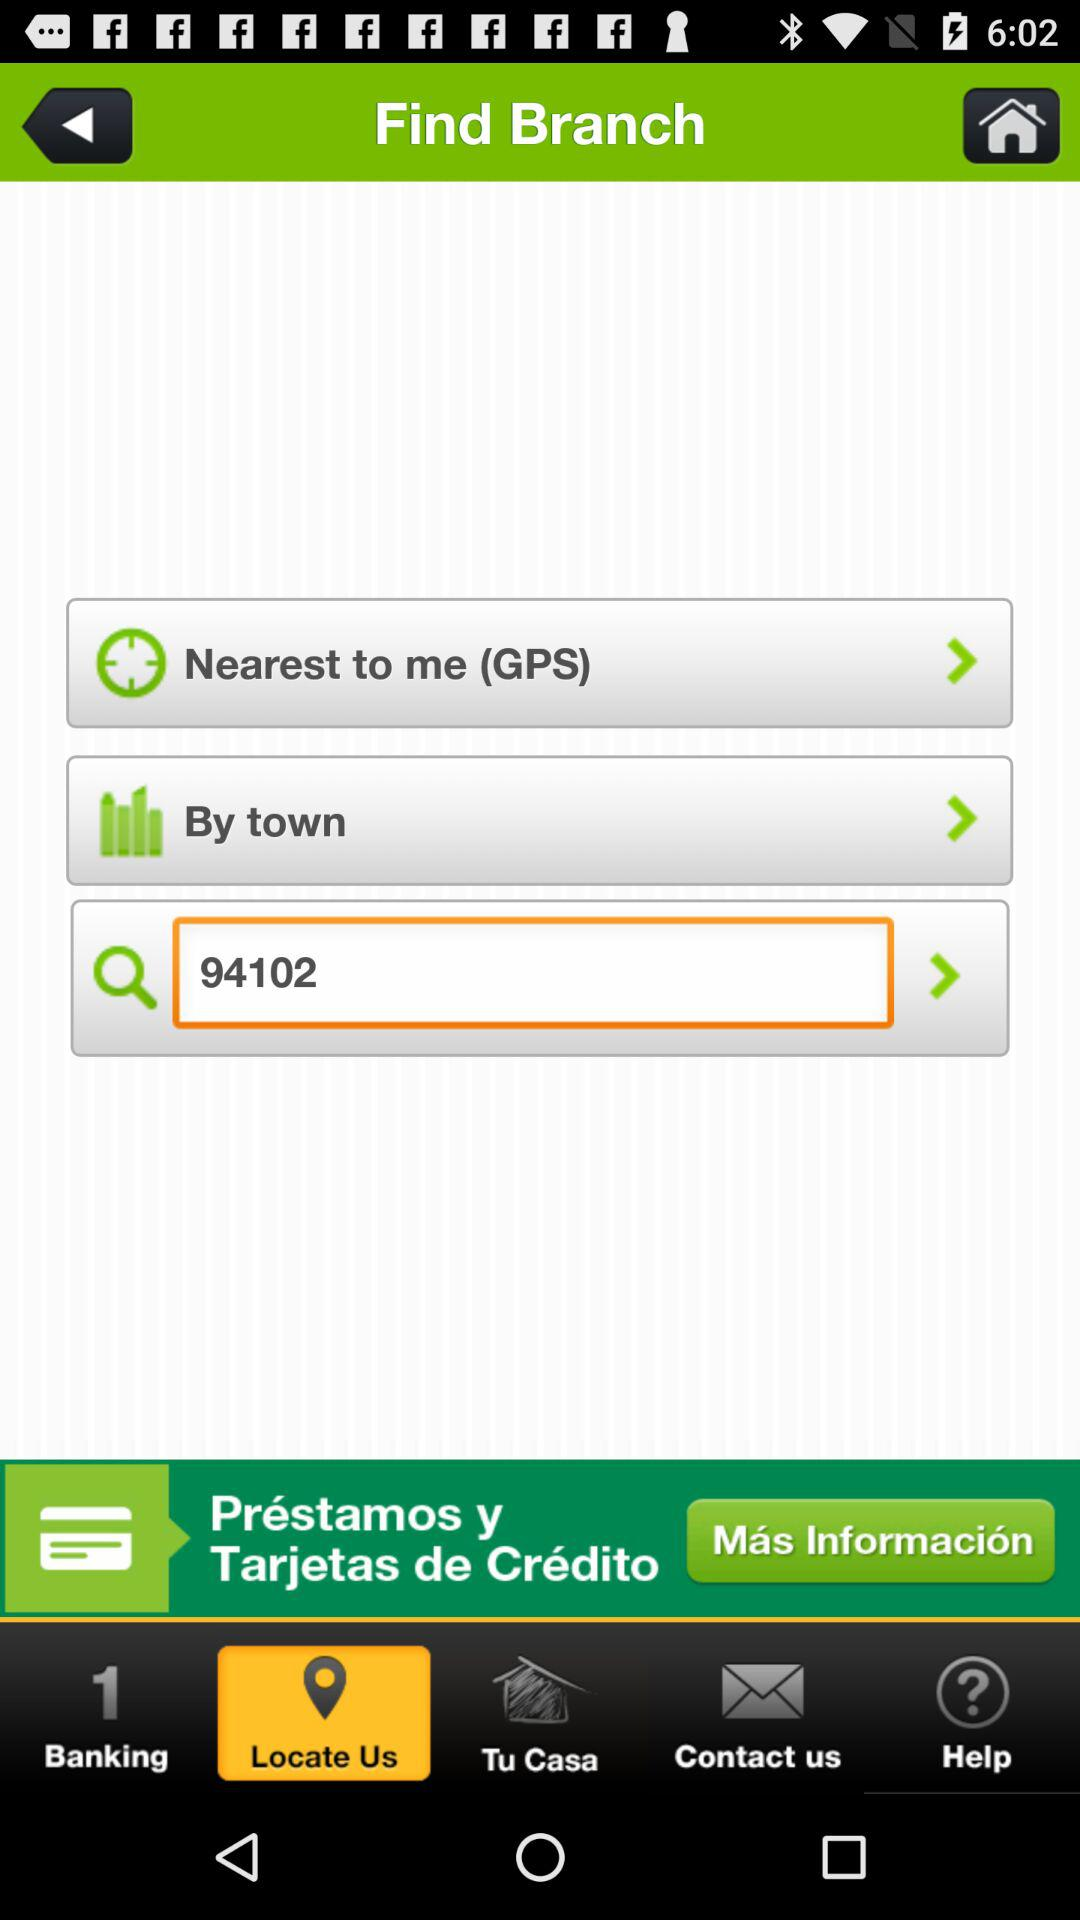Which tab has been selected in the find branch? The selected tab is "Locate Us". 